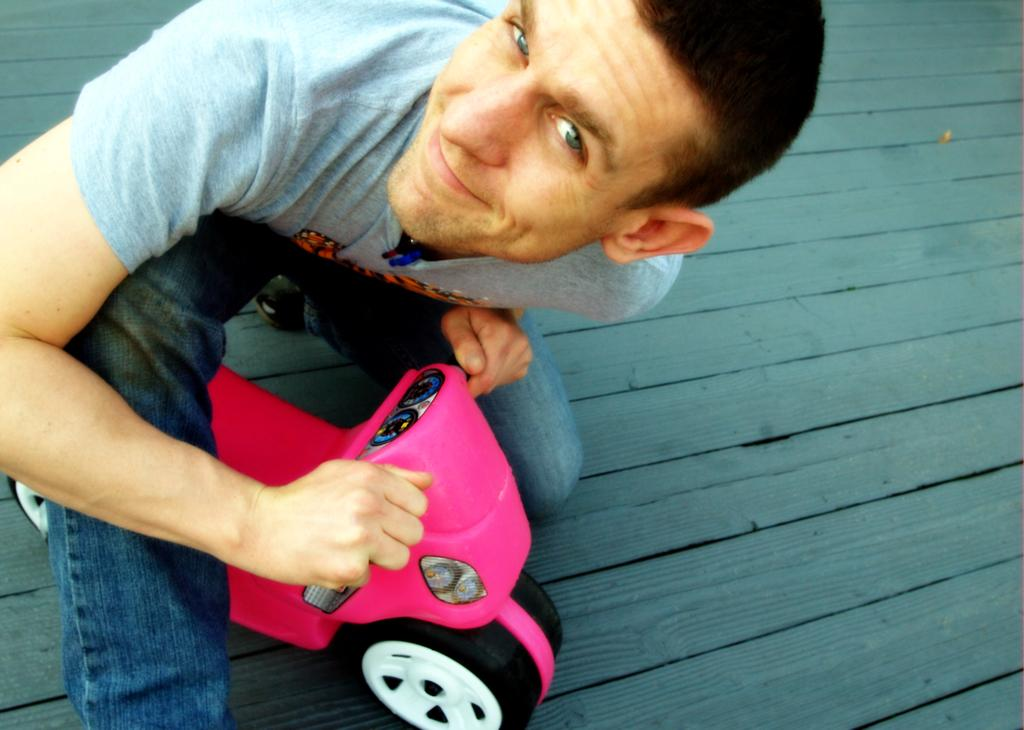What is there is a person in the image, what can you tell me about them? There is a man in the image. What is the man wearing in the image? The man is wearing a grey t-shirt and blue jeans. What is the man doing in the image? The man is sitting on a kids cycle. What type of floor is visible in the image? The floor in the image is wooden. How does the man maintain a quiet environment while sitting on the kids cycle in the image? The image does not provide any information about the man maintaining a quiet environment, nor is there any mention of a quiet environment in the image. 